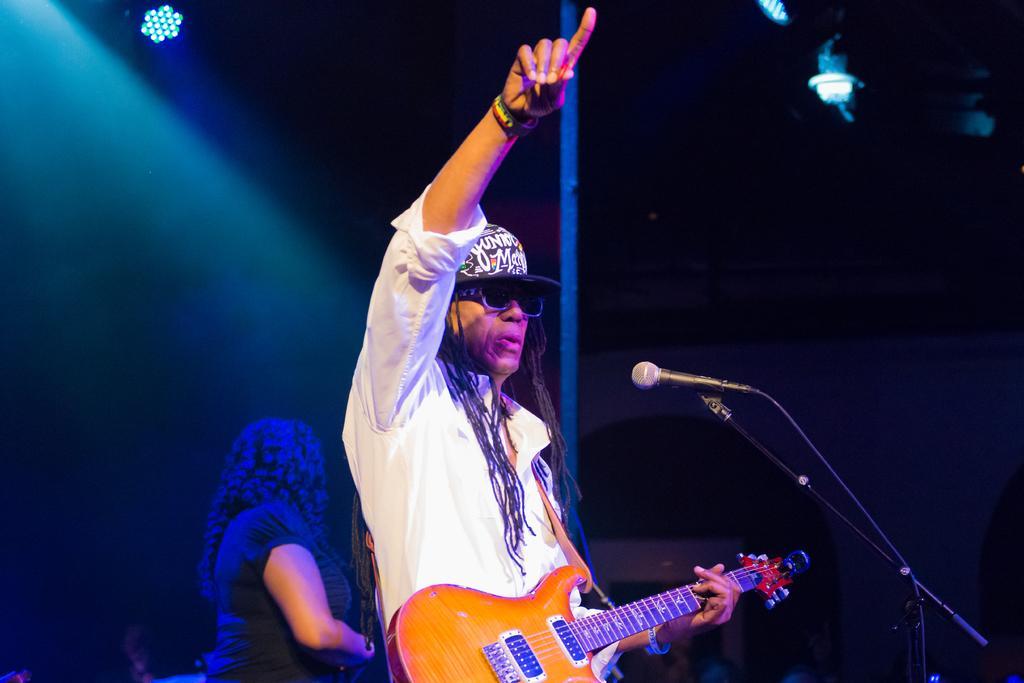Could you give a brief overview of what you see in this image? The two persons are standing on a stage. They are playing a musical instruments. They are wearing a colorful shirts. In the center we have a person. He is wearing a cap and spectacle. We can see in background lights and pole. 